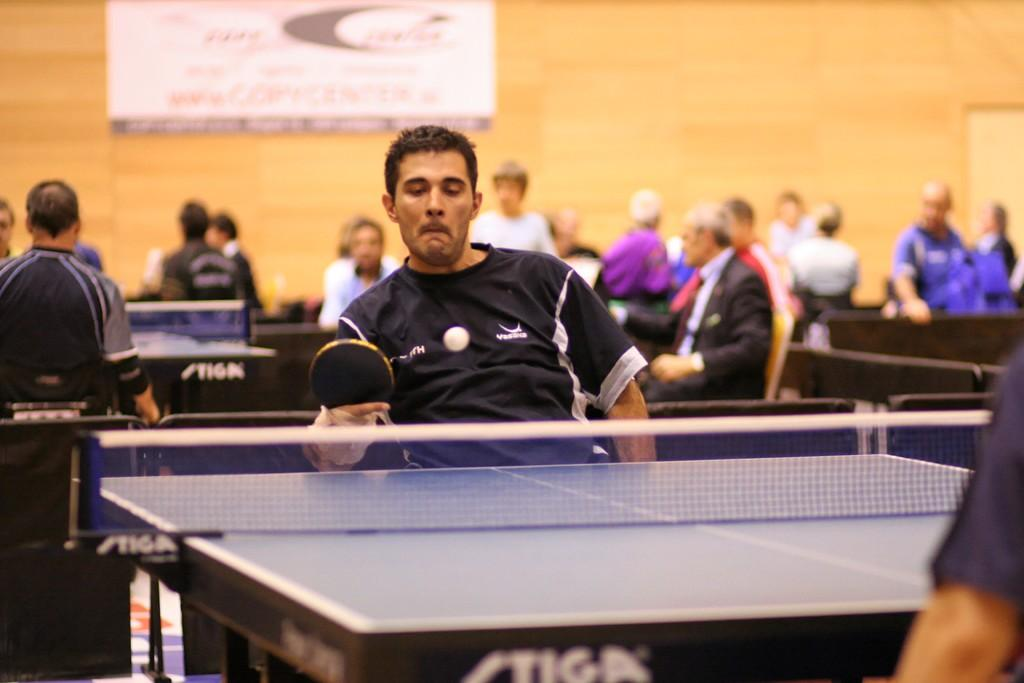What sport are the players engaged in within the image? The players are playing table tennis in the image. What can be seen in the background of the image? There is a cream-colored wall in the background of the image. What type of collar can be seen on the table tennis paddle in the image? There are no collars present in the image, as table tennis paddles do not have collars. 